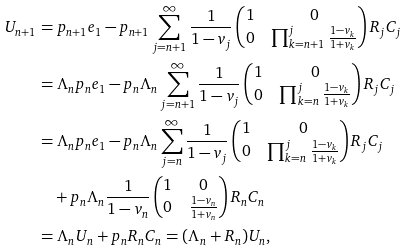<formula> <loc_0><loc_0><loc_500><loc_500>U _ { n + 1 } & = p _ { n + 1 } e _ { 1 } - p _ { n + 1 } \sum _ { j = n + 1 } ^ { \infty } \frac { 1 } { 1 - v _ { j } } \begin{pmatrix} 1 & 0 \\ 0 & \prod _ { k = n + 1 } ^ { j } \frac { 1 - v _ { k } } { 1 + v _ { k } } \end{pmatrix} R _ { j } C _ { j } \\ & = \Lambda _ { n } p _ { n } e _ { 1 } - p _ { n } \Lambda _ { n } \sum _ { j = n + 1 } ^ { \infty } \frac { 1 } { 1 - v _ { j } } \begin{pmatrix} 1 & 0 \\ 0 & \prod _ { k = n } ^ { j } \frac { 1 - v _ { k } } { 1 + v _ { k } } \end{pmatrix} R _ { j } C _ { j } \\ & = \Lambda _ { n } p _ { n } e _ { 1 } - p _ { n } \Lambda _ { n } \sum _ { j = n } ^ { \infty } \frac { 1 } { 1 - v _ { j } } \begin{pmatrix} 1 & 0 \\ 0 & \prod _ { k = n } ^ { j } \frac { 1 - v _ { k } } { 1 + v _ { k } } \end{pmatrix} R _ { j } C _ { j } \\ & \quad + p _ { n } \Lambda _ { n } \frac { 1 } { 1 - v _ { n } } \begin{pmatrix} 1 & 0 \\ 0 & \frac { 1 - v _ { n } } { 1 + v _ { n } } \end{pmatrix} R _ { n } C _ { n } \\ & = \Lambda _ { n } U _ { n } + p _ { n } R _ { n } C _ { n } = ( \Lambda _ { n } + R _ { n } ) U _ { n } ,</formula> 